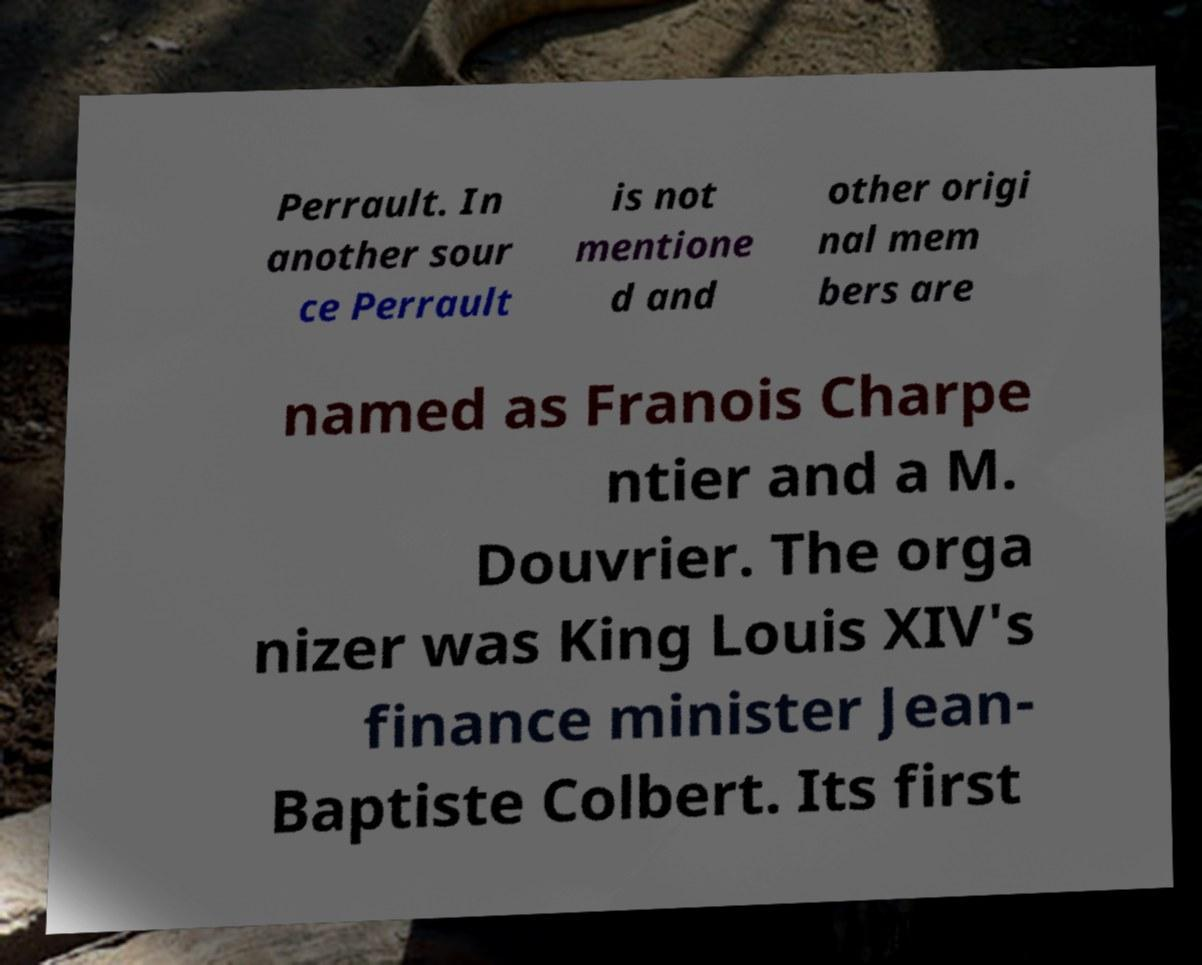What messages or text are displayed in this image? I need them in a readable, typed format. Perrault. In another sour ce Perrault is not mentione d and other origi nal mem bers are named as Franois Charpe ntier and a M. Douvrier. The orga nizer was King Louis XIV's finance minister Jean- Baptiste Colbert. Its first 